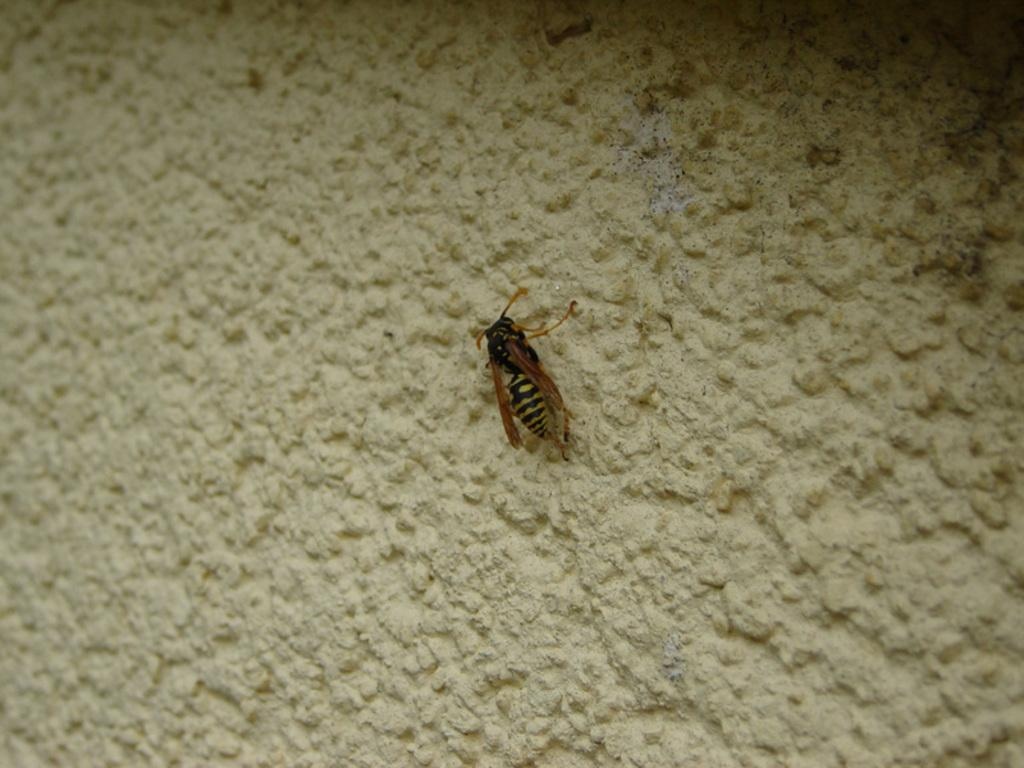What type of creature can be seen in the image? There is an insect in the image. What is the background or surface that the insect is on? The insect is on a cream-colored surface. How many cows are visible in the image? There are no cows present in the image; it features an insect on a cream-colored surface. 